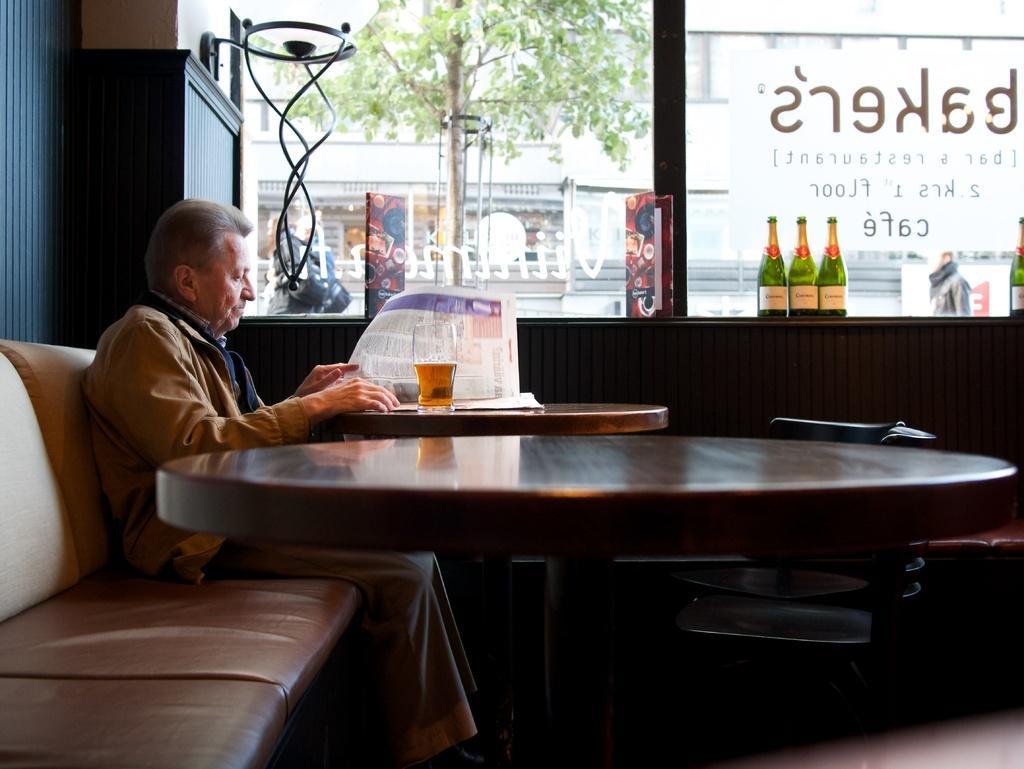How would you summarize this image in a sentence or two? In this picture we can see a man is seated on the sofa, and he is reading news paper in front of him we see a glass on the table, and also we can see couple of bottles, trees, buildings in this image. 